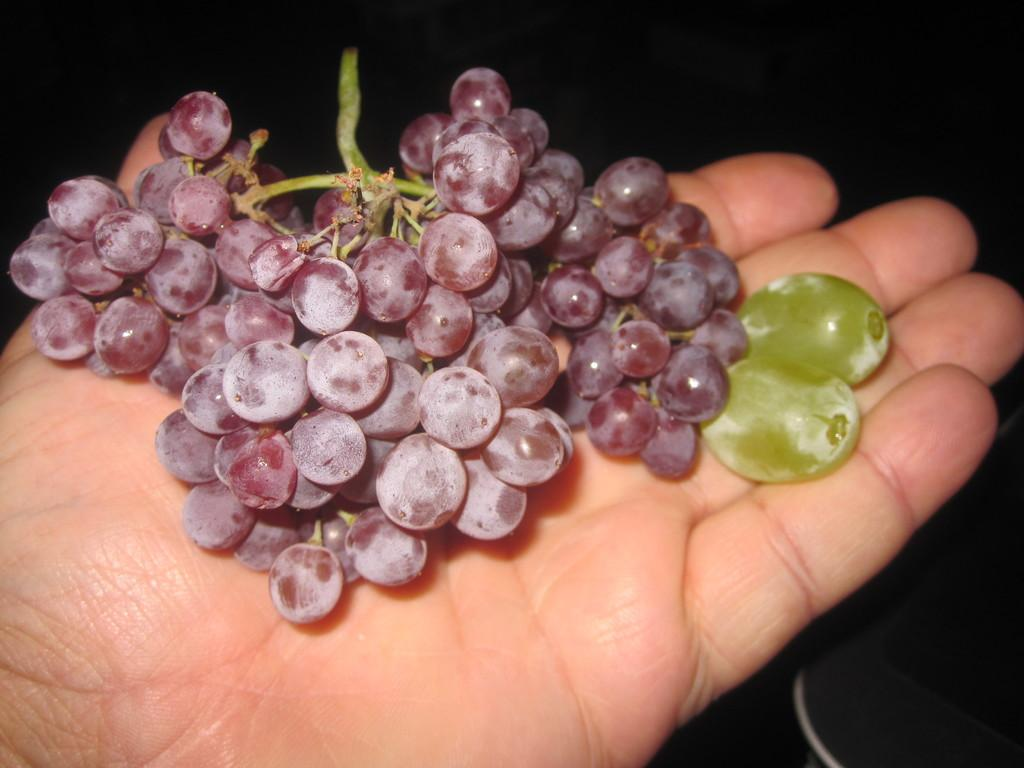What is being held in the person's hand in the image? There is a bunch of black grapes and two green grapes in the hand. Can you describe the color of the grapes in the hand? The bunch of grapes is black, and there are two green grapes in the hand. What type of education can be seen in the image? There is no reference to education in the image; it features a person's hand holding grapes. Is there any indication of pain or discomfort in the image? There is no indication of pain or discomfort in the image; it simply shows a person's hand holding grapes. 